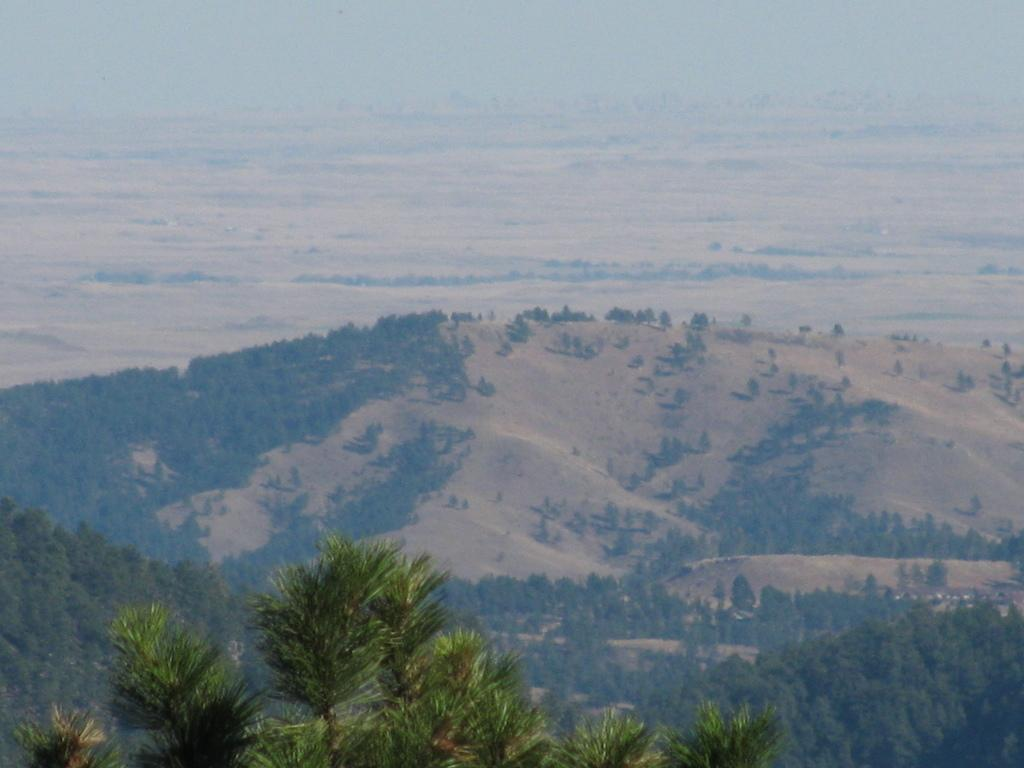What type of vegetation can be seen in the image? There are trees in the image. What is the color of the trees in the image? The trees are green in color. What can be seen in the background of the image? There are mountains and the sky visible in the background of the image. Are there trees on the mountains in the background? Yes, there are trees on the mountains in the background. What type of harbor can be seen in the image? There is no harbor present in the image; it features trees, mountains, and the sky. Who is the detail-oriented achiever in the image? There is no person or achiever mentioned in the image, as it focuses on natural elements like trees and mountains. 